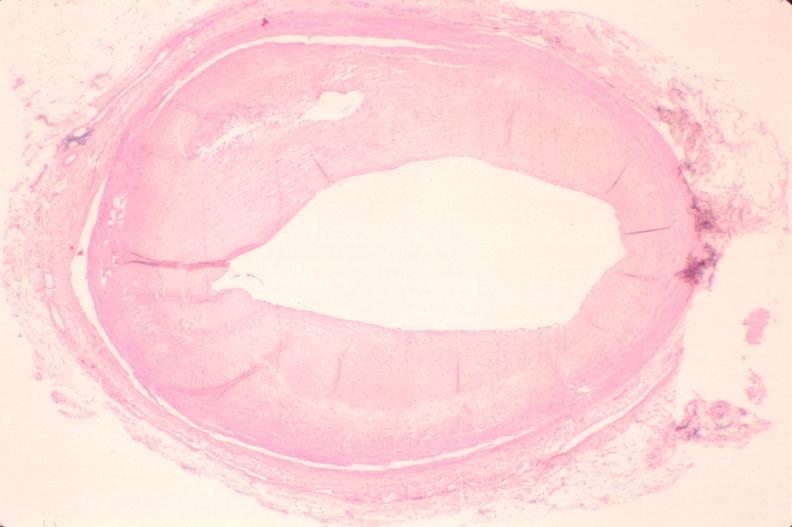does this image show atherosclerosis?
Answer the question using a single word or phrase. Yes 